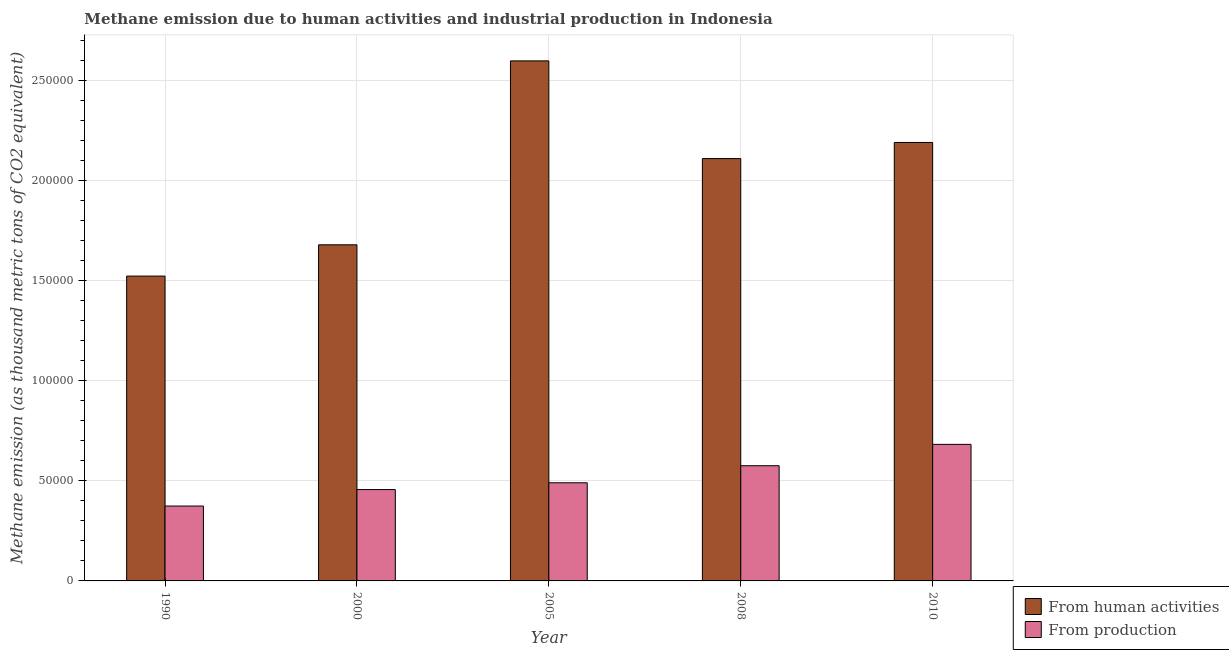How many different coloured bars are there?
Your answer should be compact. 2. How many groups of bars are there?
Ensure brevity in your answer.  5. Are the number of bars per tick equal to the number of legend labels?
Give a very brief answer. Yes. What is the label of the 2nd group of bars from the left?
Keep it short and to the point. 2000. In how many cases, is the number of bars for a given year not equal to the number of legend labels?
Your response must be concise. 0. What is the amount of emissions generated from industries in 2008?
Your response must be concise. 5.75e+04. Across all years, what is the maximum amount of emissions generated from industries?
Ensure brevity in your answer.  6.82e+04. Across all years, what is the minimum amount of emissions from human activities?
Offer a terse response. 1.52e+05. In which year was the amount of emissions from human activities minimum?
Give a very brief answer. 1990. What is the total amount of emissions from human activities in the graph?
Make the answer very short. 1.01e+06. What is the difference between the amount of emissions from human activities in 1990 and that in 2008?
Provide a succinct answer. -5.87e+04. What is the difference between the amount of emissions generated from industries in 2005 and the amount of emissions from human activities in 2008?
Offer a terse response. -8512.6. What is the average amount of emissions generated from industries per year?
Make the answer very short. 5.15e+04. What is the ratio of the amount of emissions from human activities in 1990 to that in 2005?
Ensure brevity in your answer.  0.59. Is the amount of emissions from human activities in 2000 less than that in 2005?
Provide a succinct answer. Yes. What is the difference between the highest and the second highest amount of emissions generated from industries?
Give a very brief answer. 1.07e+04. What is the difference between the highest and the lowest amount of emissions generated from industries?
Offer a very short reply. 3.08e+04. Is the sum of the amount of emissions from human activities in 2008 and 2010 greater than the maximum amount of emissions generated from industries across all years?
Offer a very short reply. Yes. What does the 1st bar from the left in 2008 represents?
Offer a very short reply. From human activities. What does the 2nd bar from the right in 2000 represents?
Keep it short and to the point. From human activities. Are all the bars in the graph horizontal?
Ensure brevity in your answer.  No. Are the values on the major ticks of Y-axis written in scientific E-notation?
Offer a terse response. No. Does the graph contain any zero values?
Ensure brevity in your answer.  No. Does the graph contain grids?
Your response must be concise. Yes. How many legend labels are there?
Ensure brevity in your answer.  2. How are the legend labels stacked?
Give a very brief answer. Vertical. What is the title of the graph?
Your response must be concise. Methane emission due to human activities and industrial production in Indonesia. Does "Travel Items" appear as one of the legend labels in the graph?
Ensure brevity in your answer.  No. What is the label or title of the X-axis?
Give a very brief answer. Year. What is the label or title of the Y-axis?
Your response must be concise. Methane emission (as thousand metric tons of CO2 equivalent). What is the Methane emission (as thousand metric tons of CO2 equivalent) in From human activities in 1990?
Provide a succinct answer. 1.52e+05. What is the Methane emission (as thousand metric tons of CO2 equivalent) in From production in 1990?
Offer a very short reply. 3.74e+04. What is the Methane emission (as thousand metric tons of CO2 equivalent) of From human activities in 2000?
Your answer should be compact. 1.68e+05. What is the Methane emission (as thousand metric tons of CO2 equivalent) of From production in 2000?
Give a very brief answer. 4.56e+04. What is the Methane emission (as thousand metric tons of CO2 equivalent) in From human activities in 2005?
Provide a short and direct response. 2.60e+05. What is the Methane emission (as thousand metric tons of CO2 equivalent) of From production in 2005?
Make the answer very short. 4.90e+04. What is the Methane emission (as thousand metric tons of CO2 equivalent) of From human activities in 2008?
Make the answer very short. 2.11e+05. What is the Methane emission (as thousand metric tons of CO2 equivalent) of From production in 2008?
Make the answer very short. 5.75e+04. What is the Methane emission (as thousand metric tons of CO2 equivalent) in From human activities in 2010?
Your answer should be compact. 2.19e+05. What is the Methane emission (as thousand metric tons of CO2 equivalent) in From production in 2010?
Your response must be concise. 6.82e+04. Across all years, what is the maximum Methane emission (as thousand metric tons of CO2 equivalent) in From human activities?
Give a very brief answer. 2.60e+05. Across all years, what is the maximum Methane emission (as thousand metric tons of CO2 equivalent) of From production?
Keep it short and to the point. 6.82e+04. Across all years, what is the minimum Methane emission (as thousand metric tons of CO2 equivalent) of From human activities?
Offer a terse response. 1.52e+05. Across all years, what is the minimum Methane emission (as thousand metric tons of CO2 equivalent) in From production?
Provide a short and direct response. 3.74e+04. What is the total Methane emission (as thousand metric tons of CO2 equivalent) in From human activities in the graph?
Make the answer very short. 1.01e+06. What is the total Methane emission (as thousand metric tons of CO2 equivalent) of From production in the graph?
Your answer should be compact. 2.58e+05. What is the difference between the Methane emission (as thousand metric tons of CO2 equivalent) in From human activities in 1990 and that in 2000?
Your response must be concise. -1.56e+04. What is the difference between the Methane emission (as thousand metric tons of CO2 equivalent) of From production in 1990 and that in 2000?
Offer a terse response. -8228.1. What is the difference between the Methane emission (as thousand metric tons of CO2 equivalent) in From human activities in 1990 and that in 2005?
Give a very brief answer. -1.07e+05. What is the difference between the Methane emission (as thousand metric tons of CO2 equivalent) of From production in 1990 and that in 2005?
Your answer should be very brief. -1.16e+04. What is the difference between the Methane emission (as thousand metric tons of CO2 equivalent) of From human activities in 1990 and that in 2008?
Make the answer very short. -5.87e+04. What is the difference between the Methane emission (as thousand metric tons of CO2 equivalent) of From production in 1990 and that in 2008?
Make the answer very short. -2.01e+04. What is the difference between the Methane emission (as thousand metric tons of CO2 equivalent) in From human activities in 1990 and that in 2010?
Ensure brevity in your answer.  -6.67e+04. What is the difference between the Methane emission (as thousand metric tons of CO2 equivalent) in From production in 1990 and that in 2010?
Provide a succinct answer. -3.08e+04. What is the difference between the Methane emission (as thousand metric tons of CO2 equivalent) of From human activities in 2000 and that in 2005?
Provide a short and direct response. -9.18e+04. What is the difference between the Methane emission (as thousand metric tons of CO2 equivalent) in From production in 2000 and that in 2005?
Your response must be concise. -3391.6. What is the difference between the Methane emission (as thousand metric tons of CO2 equivalent) of From human activities in 2000 and that in 2008?
Your response must be concise. -4.31e+04. What is the difference between the Methane emission (as thousand metric tons of CO2 equivalent) in From production in 2000 and that in 2008?
Provide a succinct answer. -1.19e+04. What is the difference between the Methane emission (as thousand metric tons of CO2 equivalent) of From human activities in 2000 and that in 2010?
Make the answer very short. -5.11e+04. What is the difference between the Methane emission (as thousand metric tons of CO2 equivalent) of From production in 2000 and that in 2010?
Offer a terse response. -2.26e+04. What is the difference between the Methane emission (as thousand metric tons of CO2 equivalent) in From human activities in 2005 and that in 2008?
Make the answer very short. 4.88e+04. What is the difference between the Methane emission (as thousand metric tons of CO2 equivalent) in From production in 2005 and that in 2008?
Give a very brief answer. -8512.6. What is the difference between the Methane emission (as thousand metric tons of CO2 equivalent) of From human activities in 2005 and that in 2010?
Give a very brief answer. 4.07e+04. What is the difference between the Methane emission (as thousand metric tons of CO2 equivalent) in From production in 2005 and that in 2010?
Make the answer very short. -1.92e+04. What is the difference between the Methane emission (as thousand metric tons of CO2 equivalent) in From human activities in 2008 and that in 2010?
Offer a very short reply. -8055.7. What is the difference between the Methane emission (as thousand metric tons of CO2 equivalent) in From production in 2008 and that in 2010?
Offer a terse response. -1.07e+04. What is the difference between the Methane emission (as thousand metric tons of CO2 equivalent) of From human activities in 1990 and the Methane emission (as thousand metric tons of CO2 equivalent) of From production in 2000?
Keep it short and to the point. 1.07e+05. What is the difference between the Methane emission (as thousand metric tons of CO2 equivalent) of From human activities in 1990 and the Methane emission (as thousand metric tons of CO2 equivalent) of From production in 2005?
Give a very brief answer. 1.03e+05. What is the difference between the Methane emission (as thousand metric tons of CO2 equivalent) in From human activities in 1990 and the Methane emission (as thousand metric tons of CO2 equivalent) in From production in 2008?
Your response must be concise. 9.47e+04. What is the difference between the Methane emission (as thousand metric tons of CO2 equivalent) of From human activities in 1990 and the Methane emission (as thousand metric tons of CO2 equivalent) of From production in 2010?
Your answer should be compact. 8.40e+04. What is the difference between the Methane emission (as thousand metric tons of CO2 equivalent) of From human activities in 2000 and the Methane emission (as thousand metric tons of CO2 equivalent) of From production in 2005?
Ensure brevity in your answer.  1.19e+05. What is the difference between the Methane emission (as thousand metric tons of CO2 equivalent) of From human activities in 2000 and the Methane emission (as thousand metric tons of CO2 equivalent) of From production in 2008?
Offer a very short reply. 1.10e+05. What is the difference between the Methane emission (as thousand metric tons of CO2 equivalent) of From human activities in 2000 and the Methane emission (as thousand metric tons of CO2 equivalent) of From production in 2010?
Offer a terse response. 9.96e+04. What is the difference between the Methane emission (as thousand metric tons of CO2 equivalent) in From human activities in 2005 and the Methane emission (as thousand metric tons of CO2 equivalent) in From production in 2008?
Offer a very short reply. 2.02e+05. What is the difference between the Methane emission (as thousand metric tons of CO2 equivalent) in From human activities in 2005 and the Methane emission (as thousand metric tons of CO2 equivalent) in From production in 2010?
Keep it short and to the point. 1.91e+05. What is the difference between the Methane emission (as thousand metric tons of CO2 equivalent) of From human activities in 2008 and the Methane emission (as thousand metric tons of CO2 equivalent) of From production in 2010?
Make the answer very short. 1.43e+05. What is the average Methane emission (as thousand metric tons of CO2 equivalent) in From human activities per year?
Provide a succinct answer. 2.02e+05. What is the average Methane emission (as thousand metric tons of CO2 equivalent) in From production per year?
Your answer should be very brief. 5.15e+04. In the year 1990, what is the difference between the Methane emission (as thousand metric tons of CO2 equivalent) in From human activities and Methane emission (as thousand metric tons of CO2 equivalent) in From production?
Keep it short and to the point. 1.15e+05. In the year 2000, what is the difference between the Methane emission (as thousand metric tons of CO2 equivalent) of From human activities and Methane emission (as thousand metric tons of CO2 equivalent) of From production?
Provide a short and direct response. 1.22e+05. In the year 2005, what is the difference between the Methane emission (as thousand metric tons of CO2 equivalent) in From human activities and Methane emission (as thousand metric tons of CO2 equivalent) in From production?
Your answer should be compact. 2.11e+05. In the year 2008, what is the difference between the Methane emission (as thousand metric tons of CO2 equivalent) in From human activities and Methane emission (as thousand metric tons of CO2 equivalent) in From production?
Provide a short and direct response. 1.53e+05. In the year 2010, what is the difference between the Methane emission (as thousand metric tons of CO2 equivalent) in From human activities and Methane emission (as thousand metric tons of CO2 equivalent) in From production?
Offer a very short reply. 1.51e+05. What is the ratio of the Methane emission (as thousand metric tons of CO2 equivalent) of From human activities in 1990 to that in 2000?
Ensure brevity in your answer.  0.91. What is the ratio of the Methane emission (as thousand metric tons of CO2 equivalent) of From production in 1990 to that in 2000?
Your response must be concise. 0.82. What is the ratio of the Methane emission (as thousand metric tons of CO2 equivalent) in From human activities in 1990 to that in 2005?
Your answer should be compact. 0.59. What is the ratio of the Methane emission (as thousand metric tons of CO2 equivalent) in From production in 1990 to that in 2005?
Give a very brief answer. 0.76. What is the ratio of the Methane emission (as thousand metric tons of CO2 equivalent) in From human activities in 1990 to that in 2008?
Ensure brevity in your answer.  0.72. What is the ratio of the Methane emission (as thousand metric tons of CO2 equivalent) of From production in 1990 to that in 2008?
Ensure brevity in your answer.  0.65. What is the ratio of the Methane emission (as thousand metric tons of CO2 equivalent) of From human activities in 1990 to that in 2010?
Provide a succinct answer. 0.7. What is the ratio of the Methane emission (as thousand metric tons of CO2 equivalent) in From production in 1990 to that in 2010?
Offer a very short reply. 0.55. What is the ratio of the Methane emission (as thousand metric tons of CO2 equivalent) in From human activities in 2000 to that in 2005?
Keep it short and to the point. 0.65. What is the ratio of the Methane emission (as thousand metric tons of CO2 equivalent) in From production in 2000 to that in 2005?
Keep it short and to the point. 0.93. What is the ratio of the Methane emission (as thousand metric tons of CO2 equivalent) of From human activities in 2000 to that in 2008?
Your response must be concise. 0.8. What is the ratio of the Methane emission (as thousand metric tons of CO2 equivalent) in From production in 2000 to that in 2008?
Ensure brevity in your answer.  0.79. What is the ratio of the Methane emission (as thousand metric tons of CO2 equivalent) of From human activities in 2000 to that in 2010?
Offer a very short reply. 0.77. What is the ratio of the Methane emission (as thousand metric tons of CO2 equivalent) in From production in 2000 to that in 2010?
Give a very brief answer. 0.67. What is the ratio of the Methane emission (as thousand metric tons of CO2 equivalent) in From human activities in 2005 to that in 2008?
Your answer should be very brief. 1.23. What is the ratio of the Methane emission (as thousand metric tons of CO2 equivalent) of From production in 2005 to that in 2008?
Offer a very short reply. 0.85. What is the ratio of the Methane emission (as thousand metric tons of CO2 equivalent) of From human activities in 2005 to that in 2010?
Provide a short and direct response. 1.19. What is the ratio of the Methane emission (as thousand metric tons of CO2 equivalent) of From production in 2005 to that in 2010?
Provide a succinct answer. 0.72. What is the ratio of the Methane emission (as thousand metric tons of CO2 equivalent) of From human activities in 2008 to that in 2010?
Your answer should be very brief. 0.96. What is the ratio of the Methane emission (as thousand metric tons of CO2 equivalent) of From production in 2008 to that in 2010?
Make the answer very short. 0.84. What is the difference between the highest and the second highest Methane emission (as thousand metric tons of CO2 equivalent) of From human activities?
Provide a succinct answer. 4.07e+04. What is the difference between the highest and the second highest Methane emission (as thousand metric tons of CO2 equivalent) of From production?
Provide a succinct answer. 1.07e+04. What is the difference between the highest and the lowest Methane emission (as thousand metric tons of CO2 equivalent) in From human activities?
Ensure brevity in your answer.  1.07e+05. What is the difference between the highest and the lowest Methane emission (as thousand metric tons of CO2 equivalent) of From production?
Make the answer very short. 3.08e+04. 